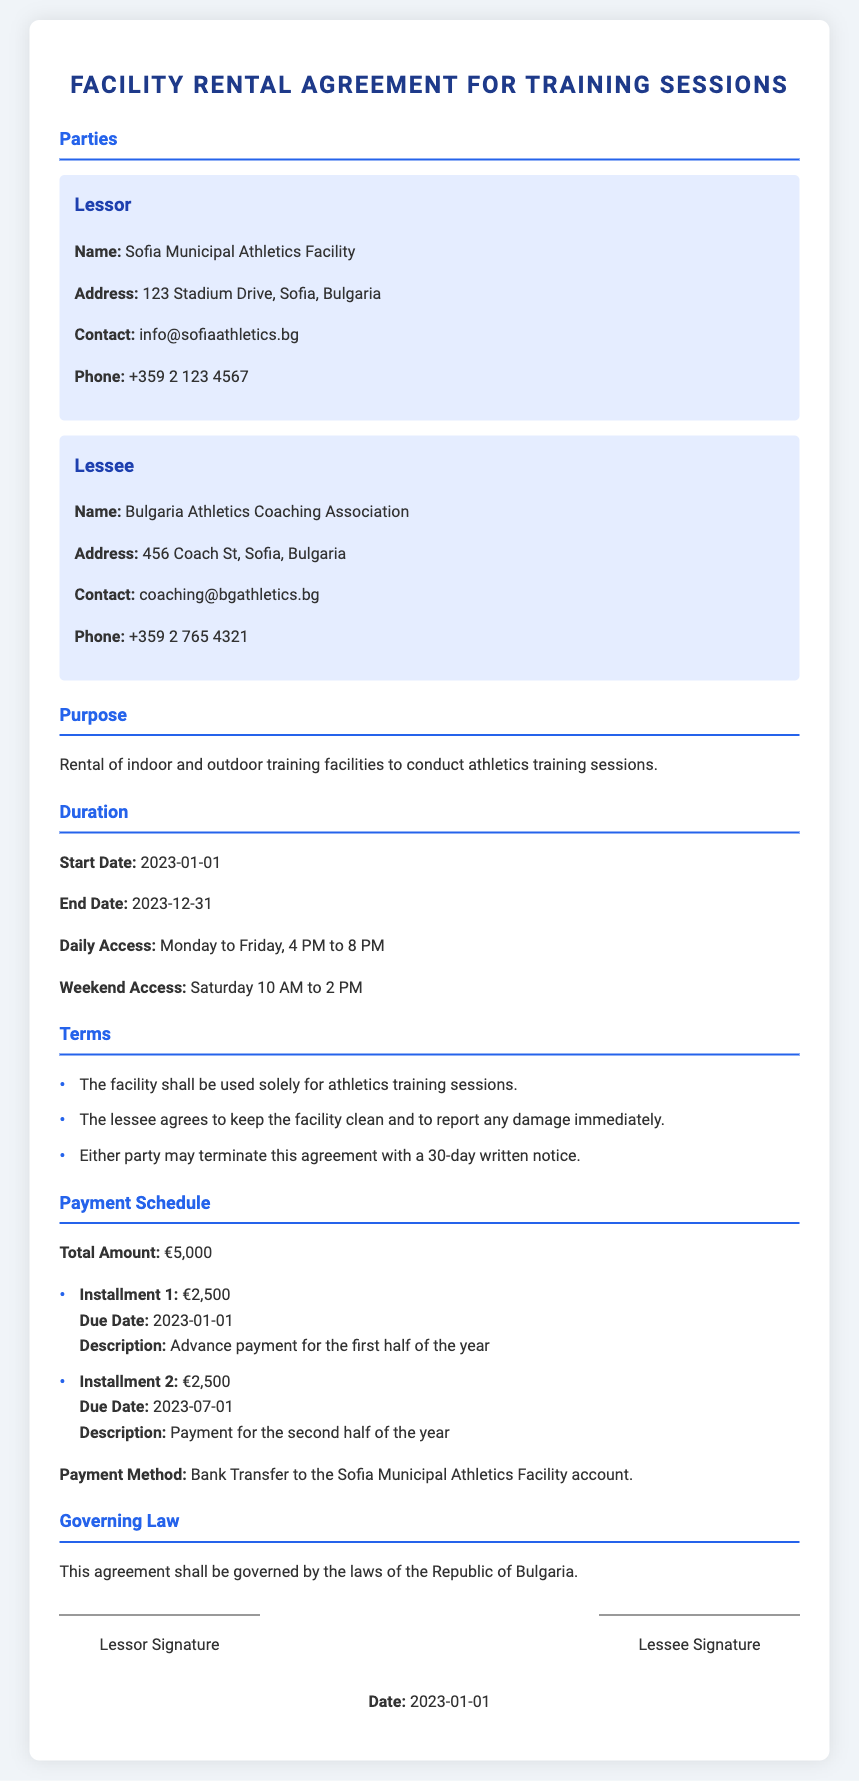What is the name of the lessor? The name of the lessor is specified in the document, which is the Sofia Municipal Athletics Facility.
Answer: Sofia Municipal Athletics Facility What is the total rental amount? The total rental amount is clearly stated in the payment schedule section of the document.
Answer: €5,000 When does the rental period start? The start date for the rental period is outlined in the duration section of the document.
Answer: 2023-01-01 What is the duration of daily access? The document specifies the days and times for access, indicating the duration of daily access.
Answer: Monday to Friday, 4 PM to 8 PM How many days' notice is required to terminate the agreement? The terms section outlines the notice period required for termination of the agreement.
Answer: 30 days What is the payment method? The document indicates how the payments should be made regarding the payment schedule.
Answer: Bank Transfer What is the due date for the second installment? The due date for the second installment is mentioned in the payment schedule section of the document.
Answer: 2023-07-01 What is the address of the lessee? The document provides the lessee's address under the parties section.
Answer: 456 Coach St, Sofia, Bulgaria 